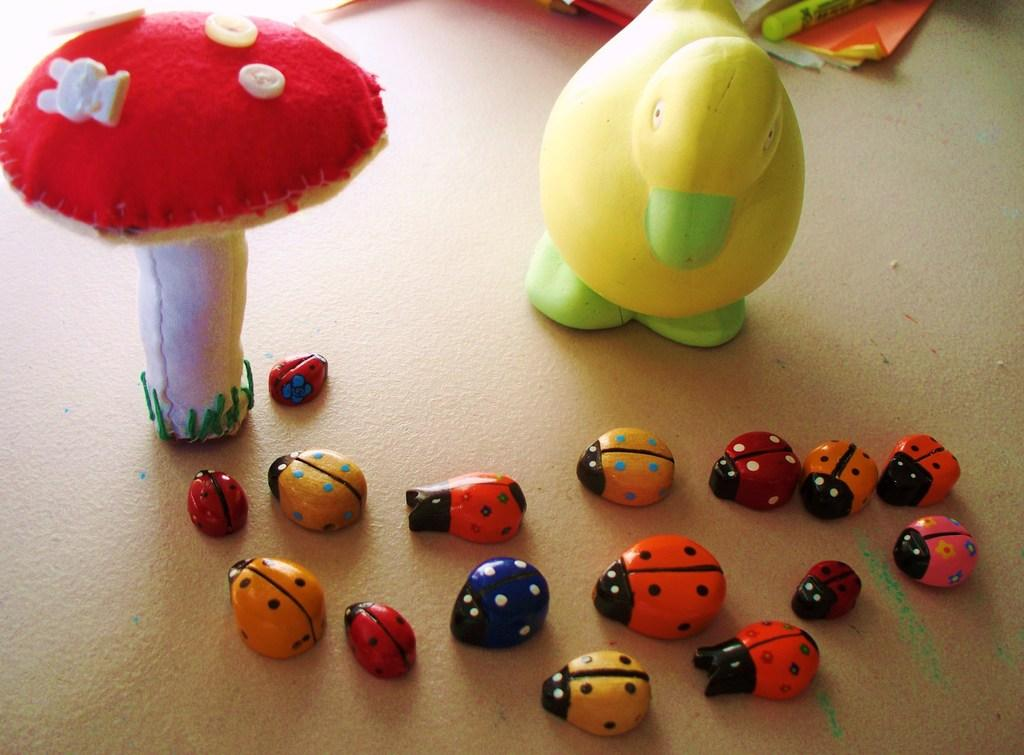What types of toys are present in the image? There are toys of ladybugs, a duck, and a mushroom in the image. Can you describe the papers in the image? The papers are placed at the top of the image. What type of cracker is being used by the spy in the crowd in the image? There is no crowd, spy, or cracker present in the image. 